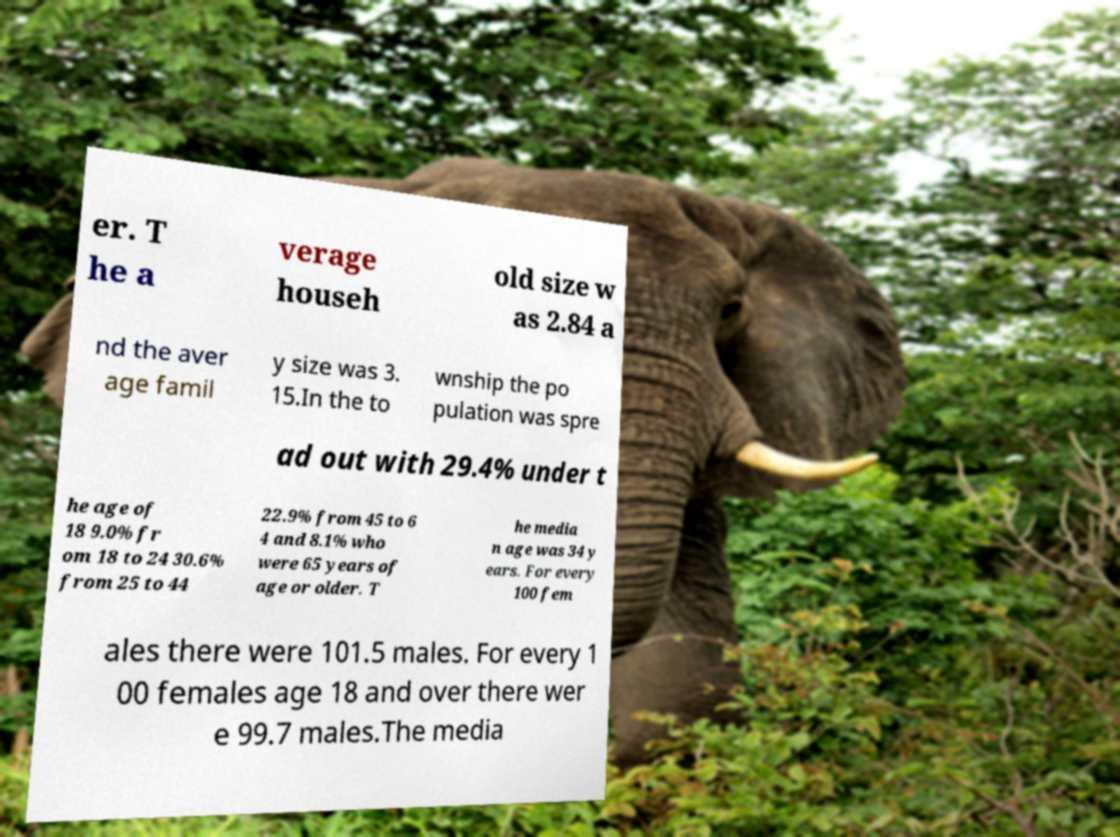Can you read and provide the text displayed in the image?This photo seems to have some interesting text. Can you extract and type it out for me? er. T he a verage househ old size w as 2.84 a nd the aver age famil y size was 3. 15.In the to wnship the po pulation was spre ad out with 29.4% under t he age of 18 9.0% fr om 18 to 24 30.6% from 25 to 44 22.9% from 45 to 6 4 and 8.1% who were 65 years of age or older. T he media n age was 34 y ears. For every 100 fem ales there were 101.5 males. For every 1 00 females age 18 and over there wer e 99.7 males.The media 